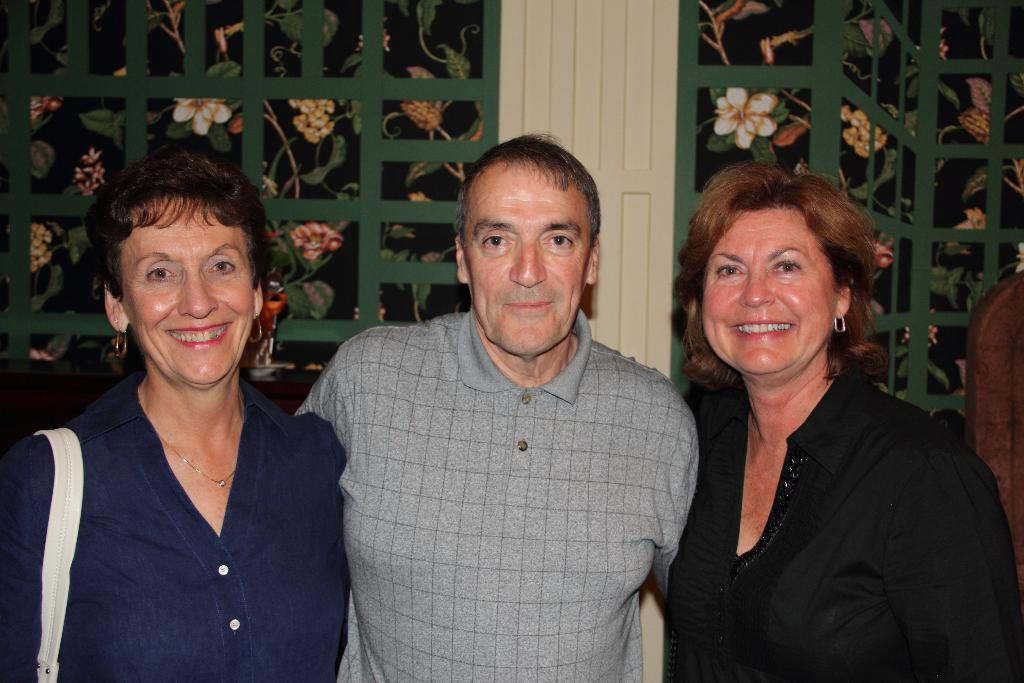What is the main subject of the image? There is a man standing in the image. Are there any other people in the image? Yes, there are two women standing on either side of the man. What can be seen in the background of the image? There is a window visible in the background of the image. What type of metal is the man's wristwatch made of in the image? There is no wristwatch visible on the man in the image, so it is not possible to determine the type of metal it might be made of. 